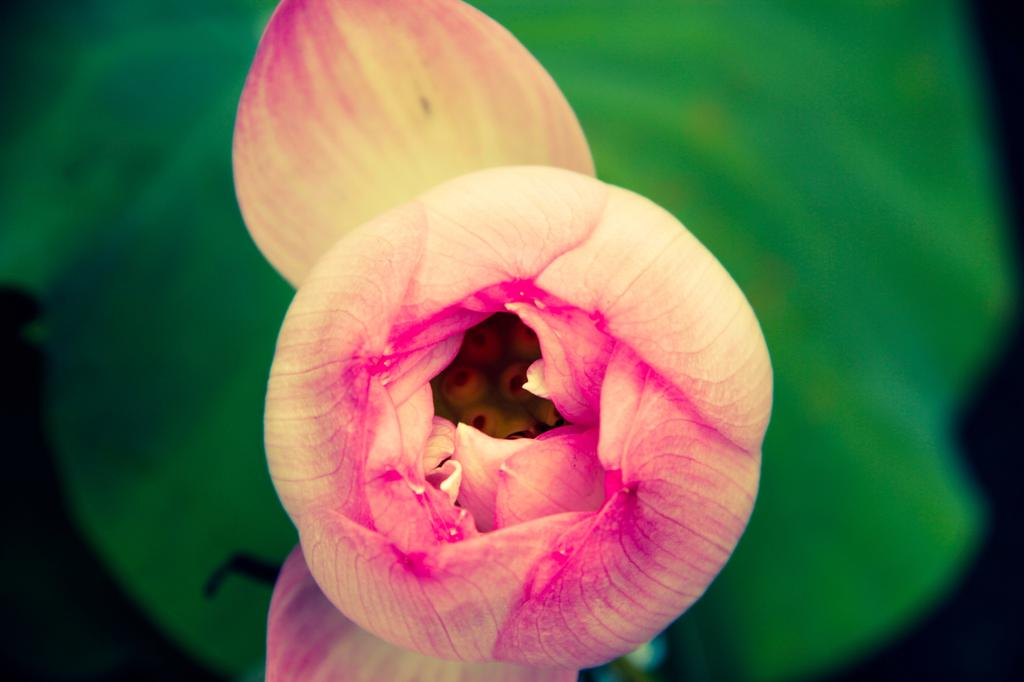What is the main subject of the image? There is a flower in the image. Can you describe the background of the image? The background of the image is blurred. What type of design can be seen on the boys' shirts in the image? There are no boys or shirts present in the image; it features a flower with a blurred background. 